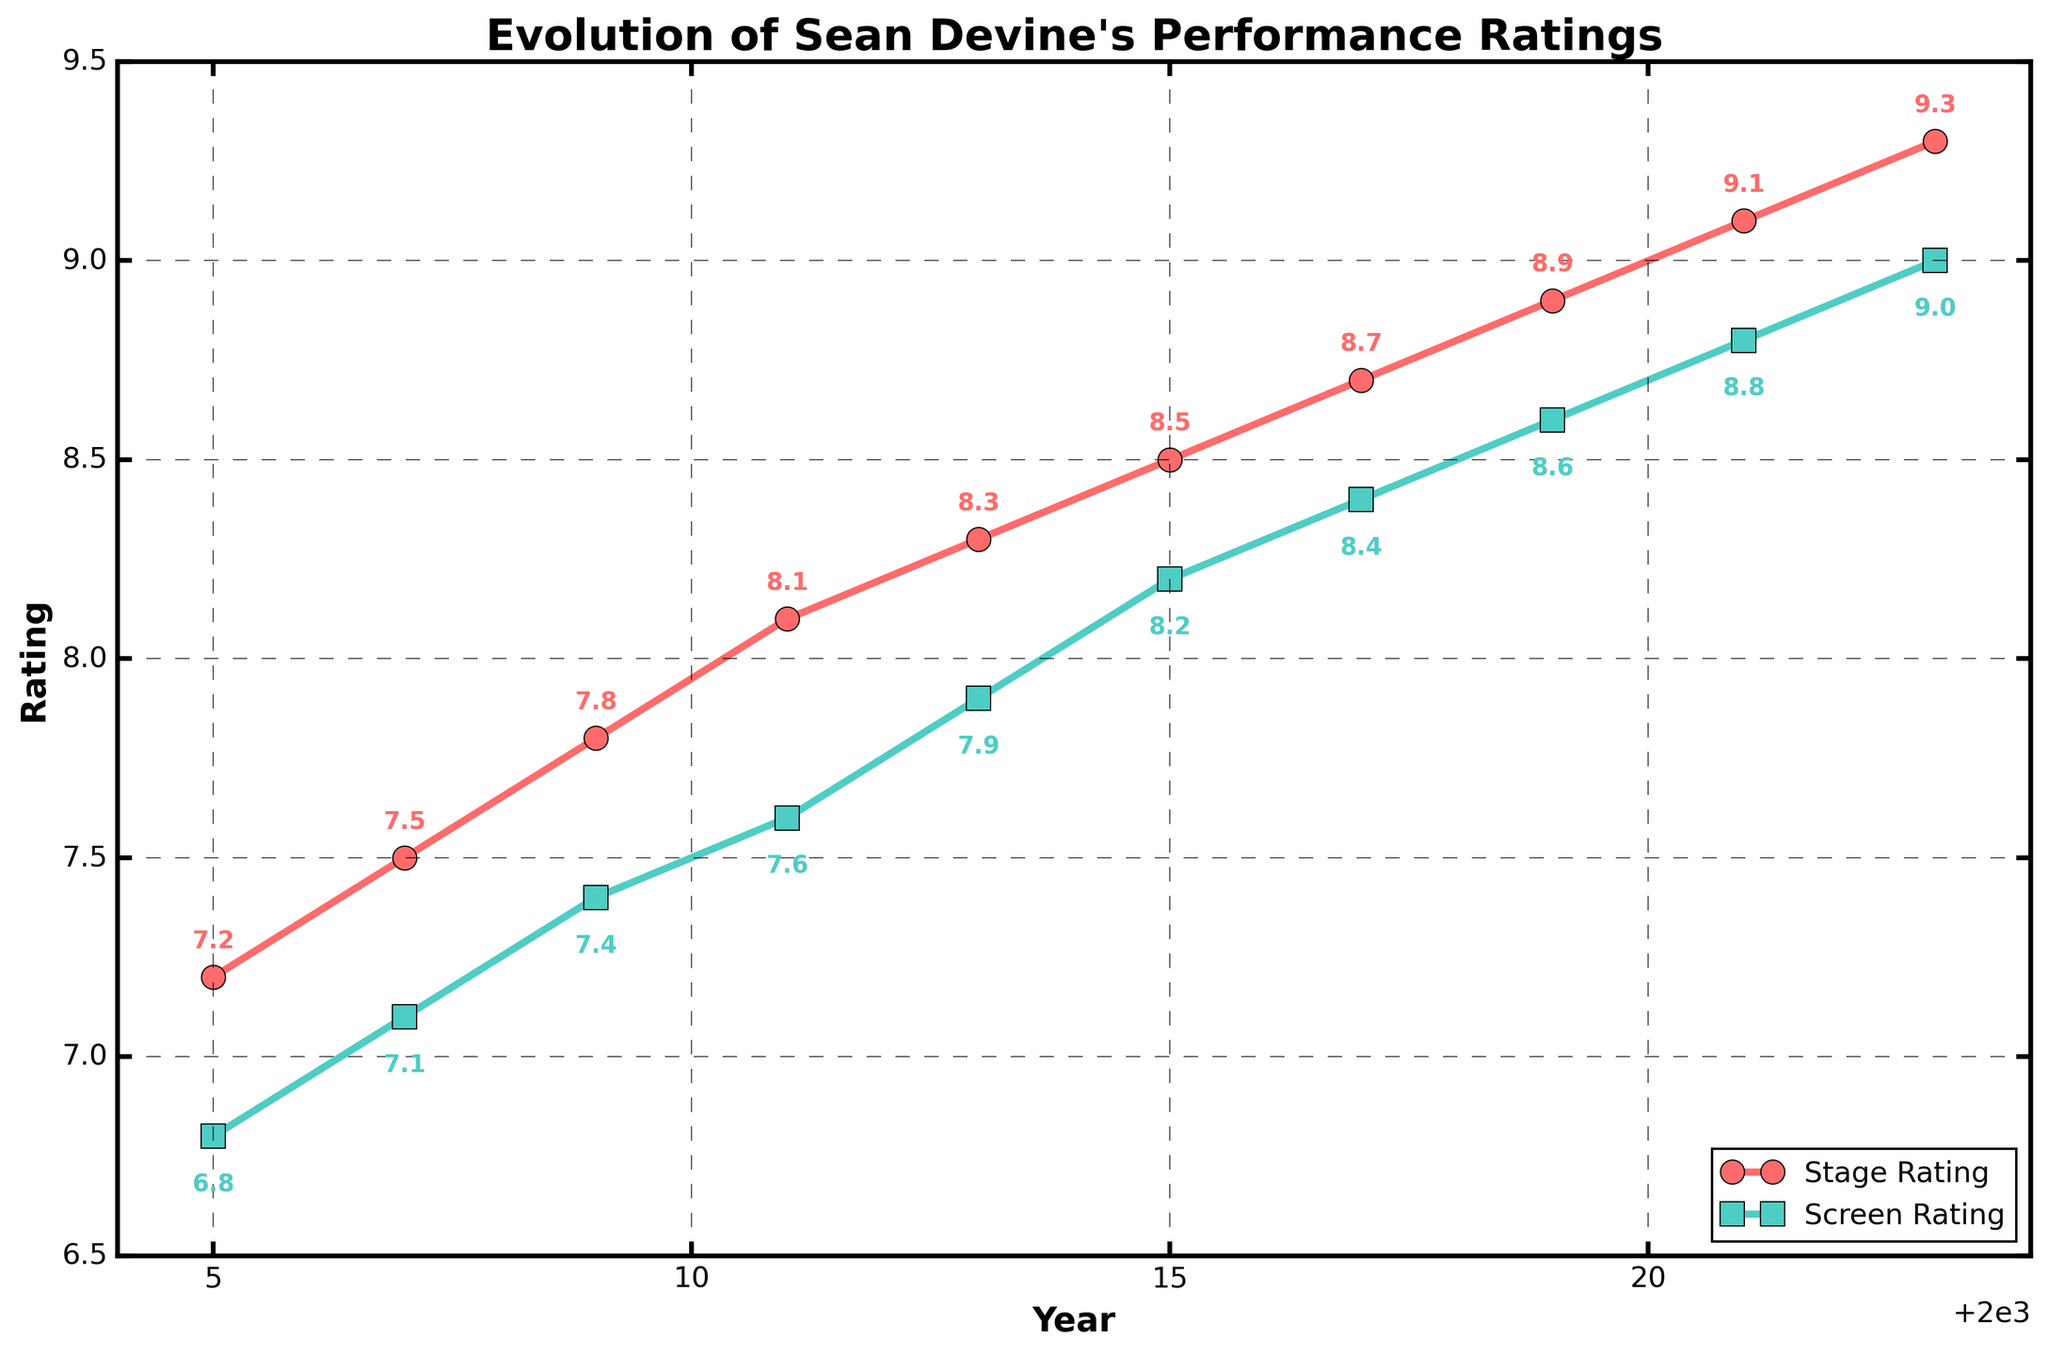What trend do you observe in the stage ratings over the years? The stage ratings have shown a steady increase from 7.2 in 2005 to 9.3 in 2023. By observing the line, it is clear that there is consistent growth in Sean Devine's stage performance ratings over time, indicating improvement.
Answer: Steady increase Which year showed the highest gap between stage and screen ratings? The highest gap can be identified by finding the year with the maximum difference between stage and screen ratings. In 2005, the difference was 7.2 - 6.8 = 0.4. Similarly, check other years: 2007 (0.4), 2009 (0.4), 2011 (0.5), 2013 (0.4), 2015 (0.3), 2017 (0.3), 2019 (0.3), 2021 (0.3), 2023 (0.3). Therefore, the highest gap of 0.5 was in 2011.
Answer: 2011 How does Sean's screen rating in 2015 compare to his stage rating in the same year? Look at the ratings for the year 2015. The stage rating is 8.5, and the screen rating is 8.2. The stage rating is slightly higher than the screen rating in 2015.
Answer: Stage rating is higher What is the overall trend for Sean's screen ratings from 2005 to 2023? Observe the screen rating line on the chart. It starts at 6.8 in 2005 and rises to 9.0 in 2023. The general trend is an upward trajectory, indicating an improvement in Sean's screen ratings over the years.
Answer: Increasing By how much did Sean's stage rating improve from 2005 to 2023? To find the improvement, subtract the 2005 stage rating from the 2023 stage rating: 9.3 - 7.2 = 2.1. Hence, Sean's stage rating improved by 2.1 points from 2005 to 2023.
Answer: 2.1 points Which category, stage or screen, showed a more consistent improvement in ratings? Compare the line smoothness and trend for both categories. The stage rating line is smooth without dips, showing a steady and consistent rise. The screen rating also increases but slightly less smoothly. Thus, stage ratings show a more consistent improvement.
Answer: Stage What is the average stage rating between 2005 and 2023? Sum all the stage ratings from 2005 to 2023: 7.2 + 7.5 + 7.8 + 8.1 + 8.3 + 8.5 + 8.7 + 8.9 + 9.1 + 9.3 = 83.4. There are 10 data points, so average = 83.4 / 10 = 8.34.
Answer: 8.34 In which year did both stage and screen ratings reach 8.8 or higher? Check the points where stage rating is at least 8.8 and screen rating is at least 8.8. In 2021 and 2023, both exceed 8.8: stage rating is 9.1 and 9.3, screen rating is 8.8 and 9.0.
Answer: 2021 and 2023 What visual elements differentiate stage and screen ratings in the chart? The stage ratings are plotted with red circles and lines, while the screen ratings use green squares and lines. Additionally, annotations and axis labels help differentiate these categories visually.
Answer: Color and shape of markers What is the difference between stage and screen ratings in 2023? Look at the year 2023; the stage rating is 9.3 and the screen rating is 9.0. Subtract screen rating from stage rating: 9.3 - 9.0 = 0.3. Hence, the difference is 0.3.
Answer: 0.3 